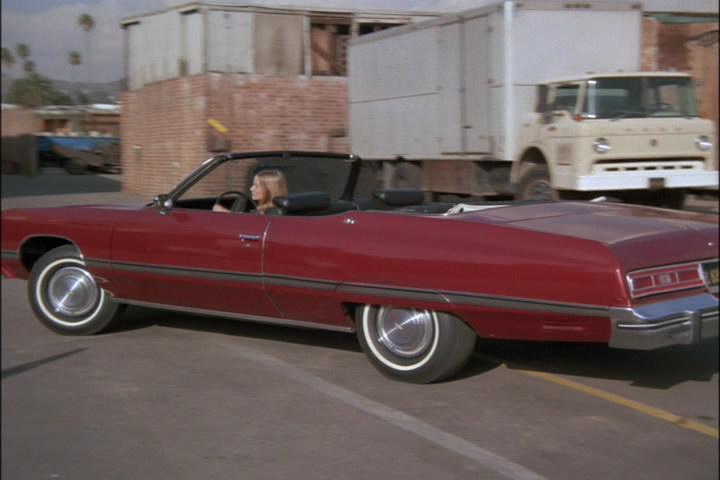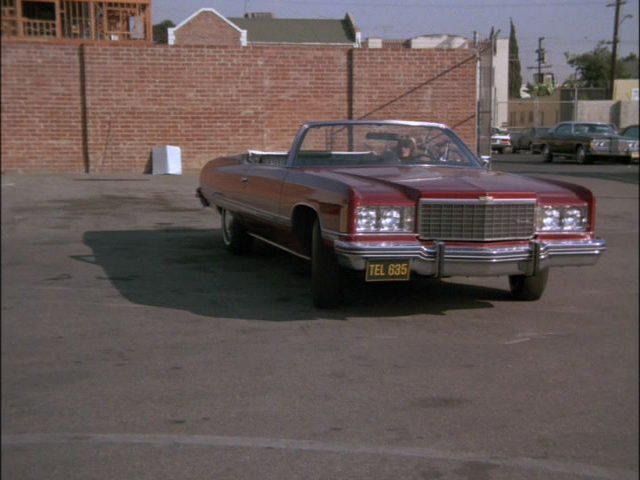The first image is the image on the left, the second image is the image on the right. Examine the images to the left and right. Is the description "A human is standing in front of a car in one photo." accurate? Answer yes or no. No. The first image is the image on the left, the second image is the image on the right. Analyze the images presented: Is the assertion "An image shows a young male standing at the front of a beat-up looking convertible." valid? Answer yes or no. No. 